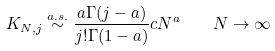Convert formula to latex. <formula><loc_0><loc_0><loc_500><loc_500>K _ { N , j } \stackrel { a . s . } { \sim } \frac { a \Gamma ( j - a ) } { j ! \Gamma ( 1 - a ) } c N ^ { a } \quad N \rightarrow \infty</formula> 